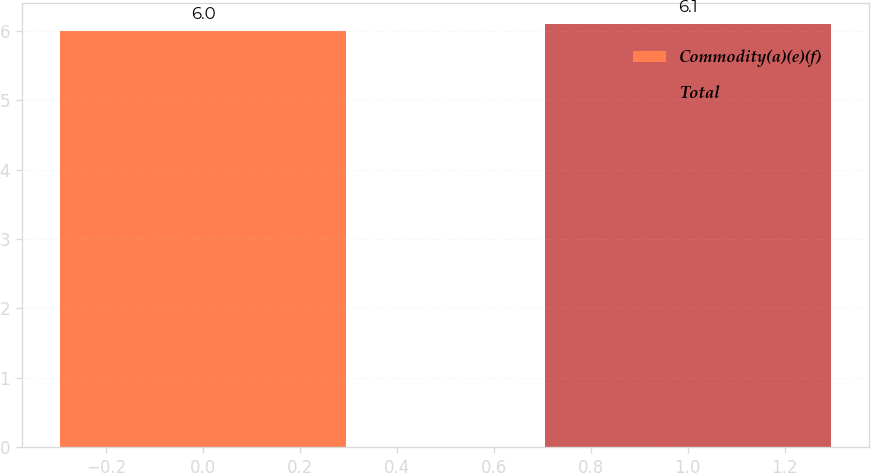Convert chart. <chart><loc_0><loc_0><loc_500><loc_500><bar_chart><fcel>Commodity(a)(e)(f)<fcel>Total<nl><fcel>6<fcel>6.1<nl></chart> 